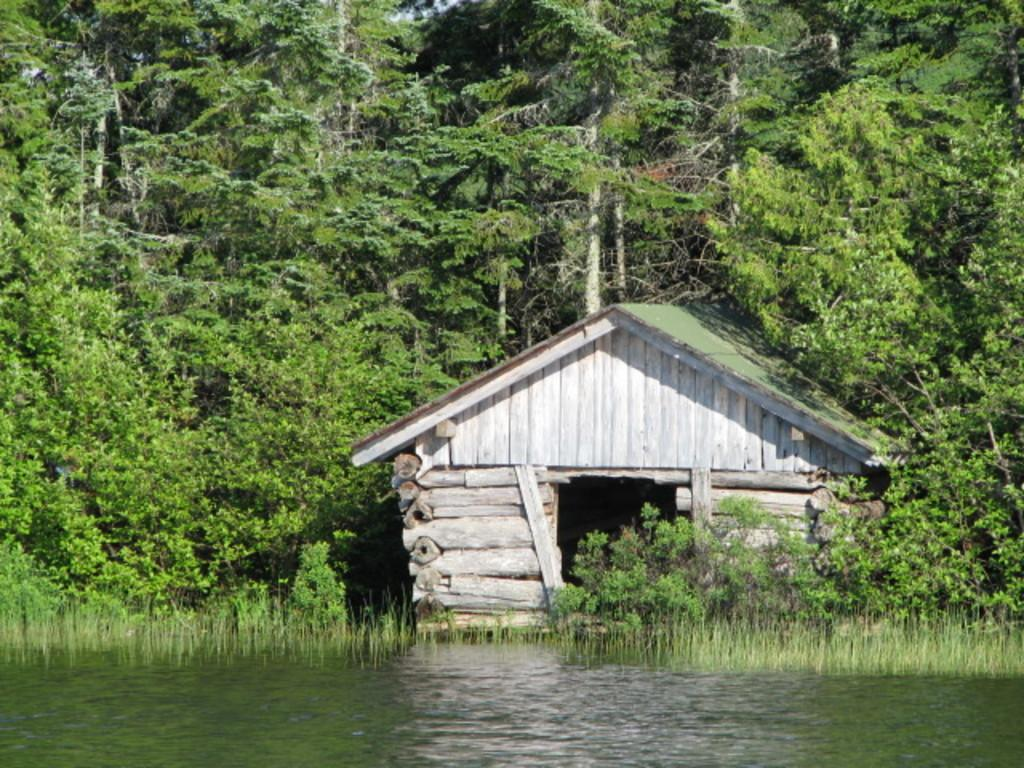What type of structure is present in the image? There is a house in the image. What is located in front of the house? Water and grass are visible in front of the house. What type of vegetation is present in the image? There are trees in the image. What can be seen in the background of the image? The sky is visible in the image. What type of pie is being baked in the oven inside the house? There is no indication of an oven or pie in the image; it only shows a house with water, grass, trees, and the sky visible. 